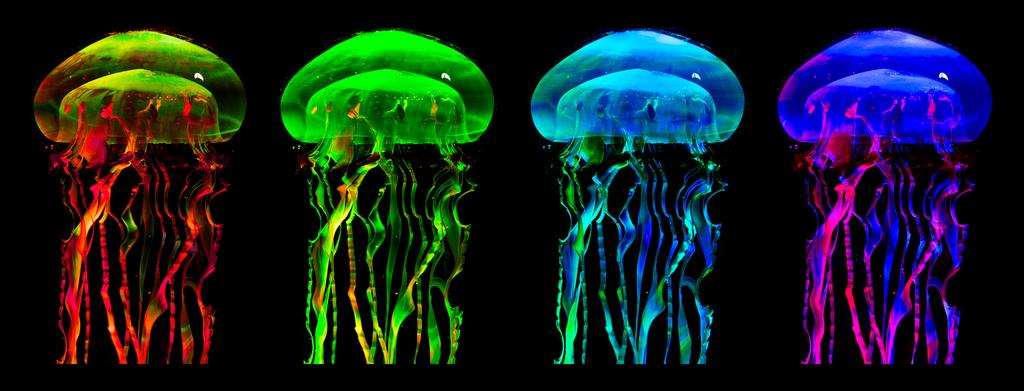How many jellyfishes are in the picture? There are four jellyfishes in the picture. What are the colors of the jellyfishes? The jellyfishes have different colors: green, yellow, blue, and pink. What time of day is it in the picture, and are there any boys or pipes present? The time of day is not mentioned in the image, and there are no boys or pipes present in the picture. 